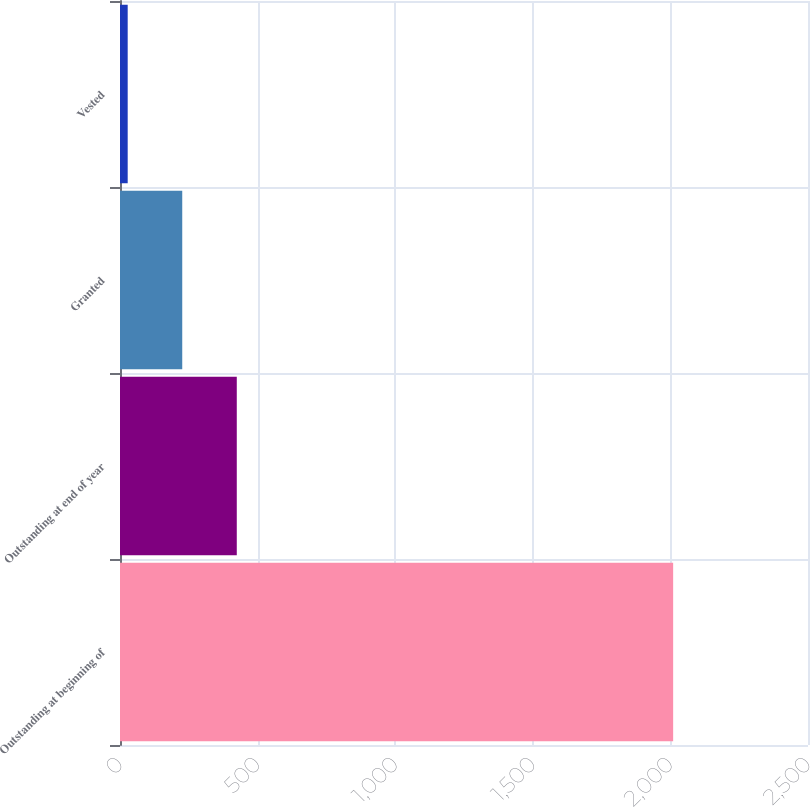Convert chart. <chart><loc_0><loc_0><loc_500><loc_500><bar_chart><fcel>Outstanding at beginning of<fcel>Outstanding at end of year<fcel>Granted<fcel>Vested<nl><fcel>2010<fcel>424.36<fcel>226.16<fcel>27.96<nl></chart> 